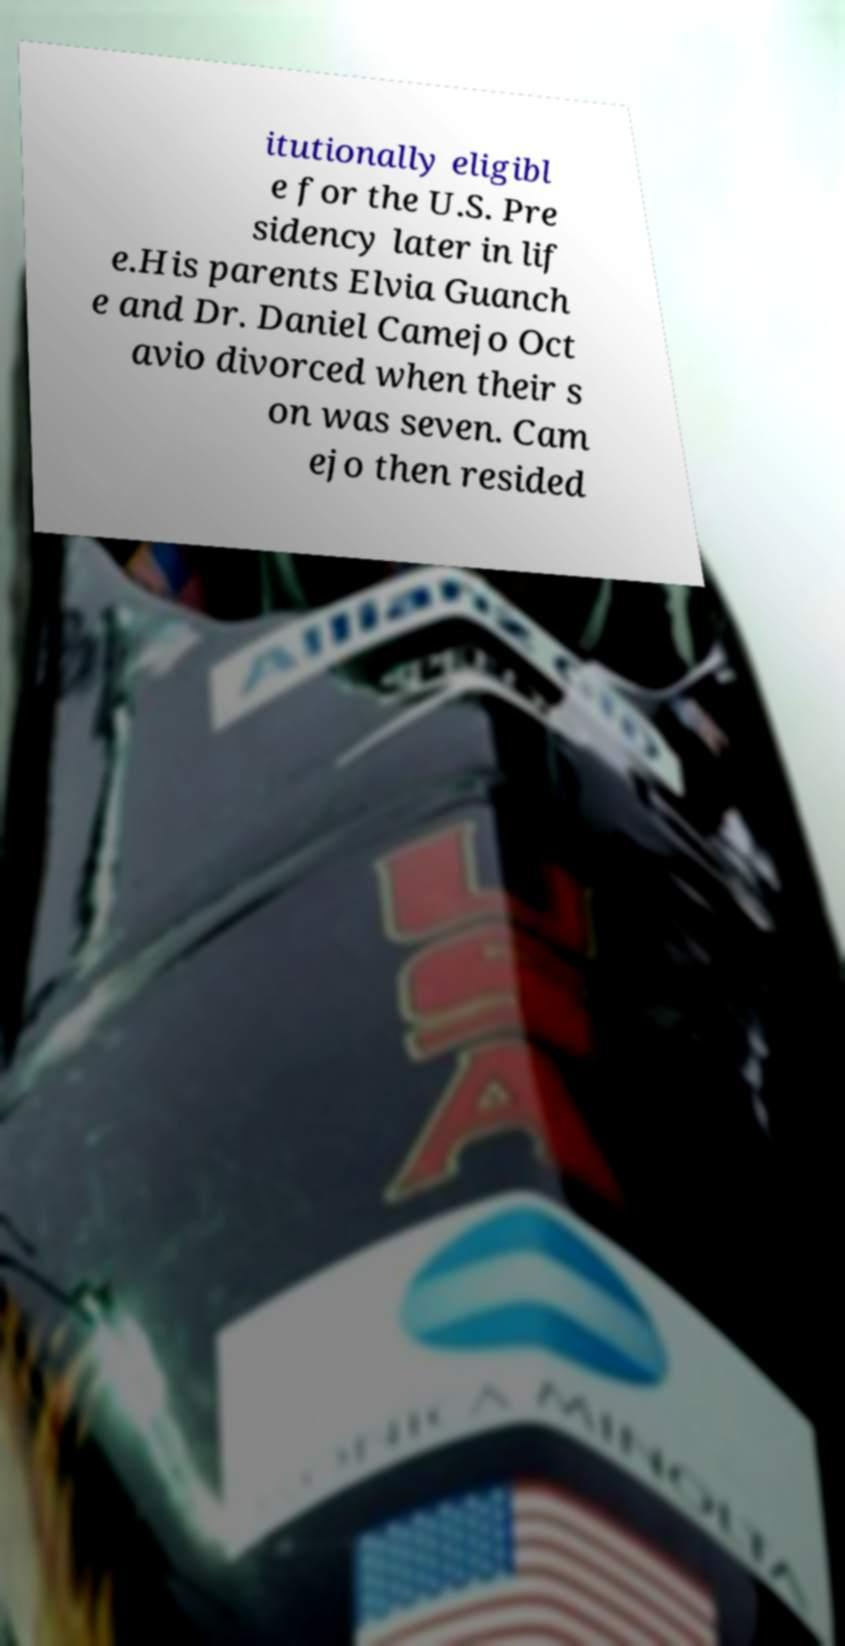There's text embedded in this image that I need extracted. Can you transcribe it verbatim? itutionally eligibl e for the U.S. Pre sidency later in lif e.His parents Elvia Guanch e and Dr. Daniel Camejo Oct avio divorced when their s on was seven. Cam ejo then resided 